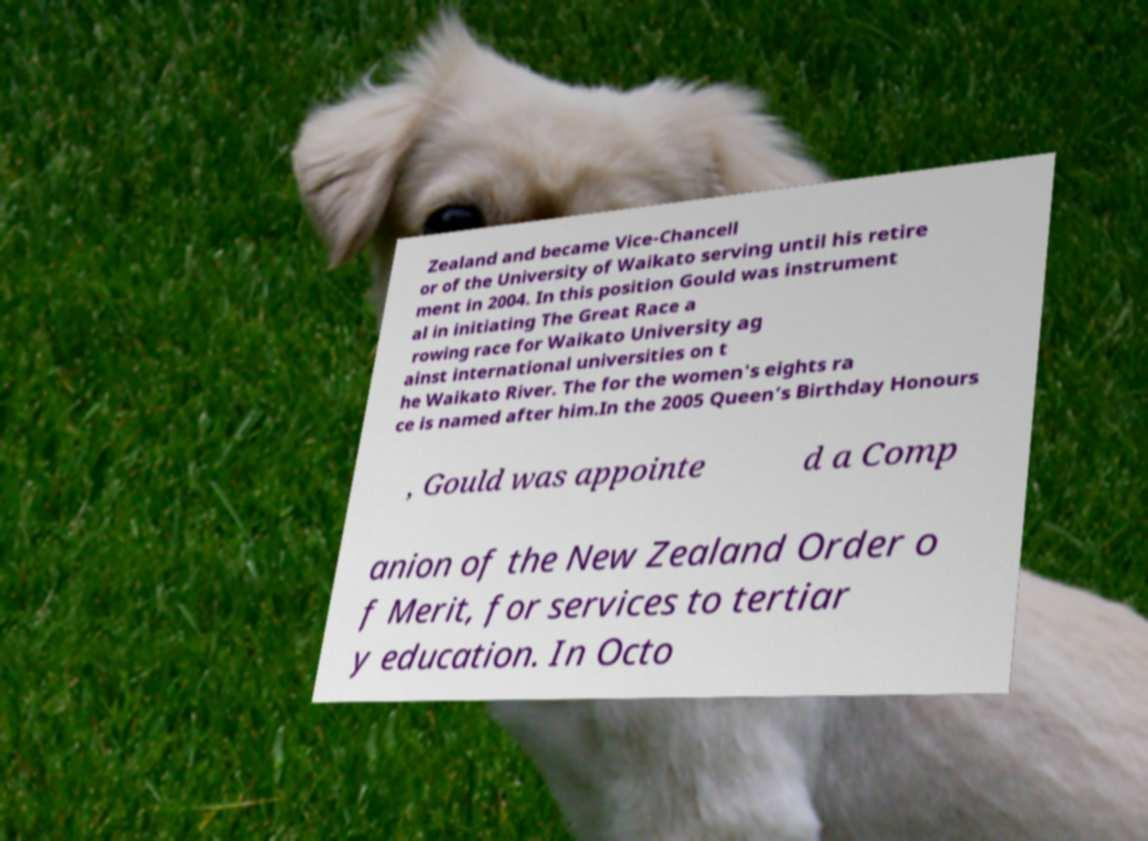Can you accurately transcribe the text from the provided image for me? Zealand and became Vice-Chancell or of the University of Waikato serving until his retire ment in 2004. In this position Gould was instrument al in initiating The Great Race a rowing race for Waikato University ag ainst international universities on t he Waikato River. The for the women's eights ra ce is named after him.In the 2005 Queen’s Birthday Honours , Gould was appointe d a Comp anion of the New Zealand Order o f Merit, for services to tertiar y education. In Octo 